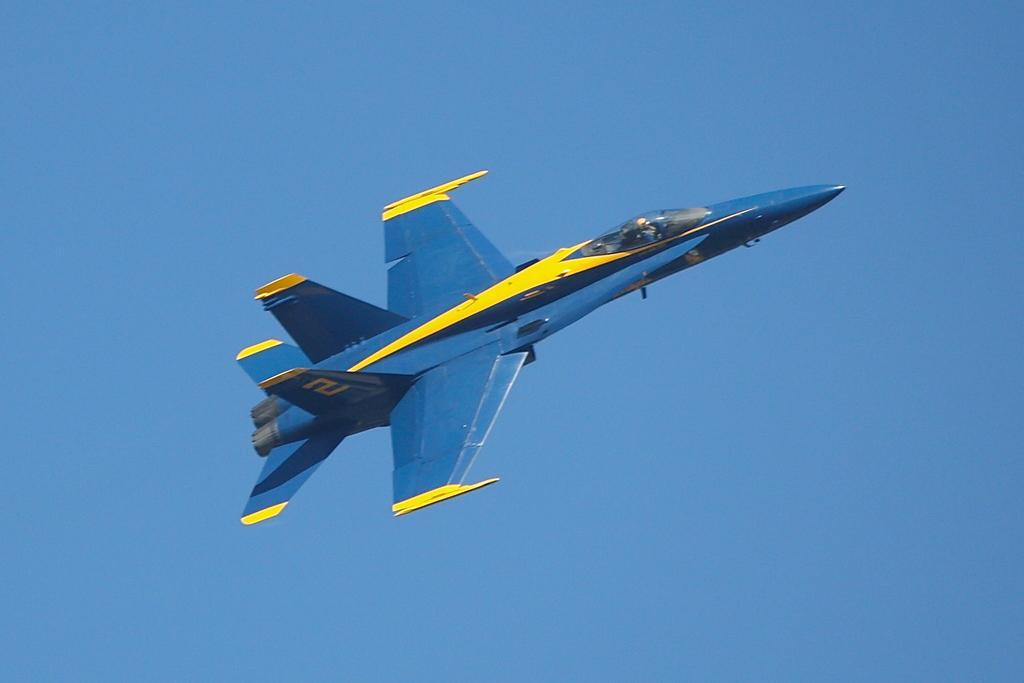Can you describe this image briefly? An aeroplane is flying in an air which is in blue color. This is the sky. 